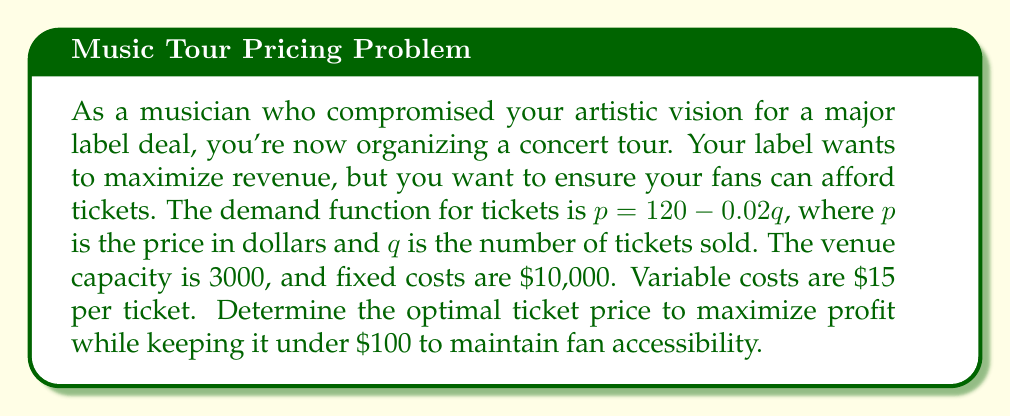Show me your answer to this math problem. 1) First, let's formulate the profit function $\Pi(q)$:
   Revenue = $pq = (120 - 0.02q)q = 120q - 0.02q^2$
   Total Cost = Fixed Cost + Variable Cost = $10,000 + 15q$
   $\Pi(q) = 120q - 0.02q^2 - 15q - 10,000 = 105q - 0.02q^2 - 10,000$

2) To maximize profit, we find where $\frac{d\Pi}{dq} = 0$:
   $\frac{d\Pi}{dq} = 105 - 0.04q$
   $105 - 0.04q = 0$
   $q = 2625$

3) Check the second derivative to confirm it's a maximum:
   $\frac{d^2\Pi}{dq^2} = -0.04 < 0$, confirming a maximum.

4) Calculate the optimal price:
   $p = 120 - 0.02(2625) = 67.50$

5) Verify that this price is under $100 as required.

6) Check if $q = 2625$ is within the venue capacity of 3000.

7) Calculate the maximum profit:
   $\Pi(2625) = 105(2625) - 0.02(2625)^2 - 10,000 = 137,812.50$
Answer: $67.50 